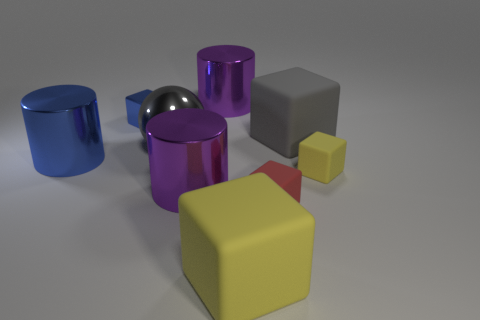How many things are things that are to the left of the big ball or big purple metal objects in front of the tiny yellow cube?
Your answer should be compact. 3. What is the material of the blue thing that is the same size as the red rubber block?
Give a very brief answer. Metal. What number of other things are there of the same material as the blue cylinder
Ensure brevity in your answer.  4. Is the shape of the blue metallic thing in front of the large ball the same as the purple metallic thing that is in front of the gray shiny ball?
Your answer should be compact. Yes. There is a big matte cube that is behind the small red thing that is behind the rubber thing that is in front of the red block; what is its color?
Your response must be concise. Gray. How many other things are the same color as the tiny shiny cube?
Keep it short and to the point. 1. Is the number of cyan spheres less than the number of large things?
Make the answer very short. Yes. The metallic thing that is both behind the gray cube and left of the large gray ball is what color?
Your answer should be very brief. Blue. There is a tiny yellow object that is the same shape as the gray matte object; what is it made of?
Offer a terse response. Rubber. Is the number of big metal objects greater than the number of large rubber balls?
Provide a succinct answer. Yes. 